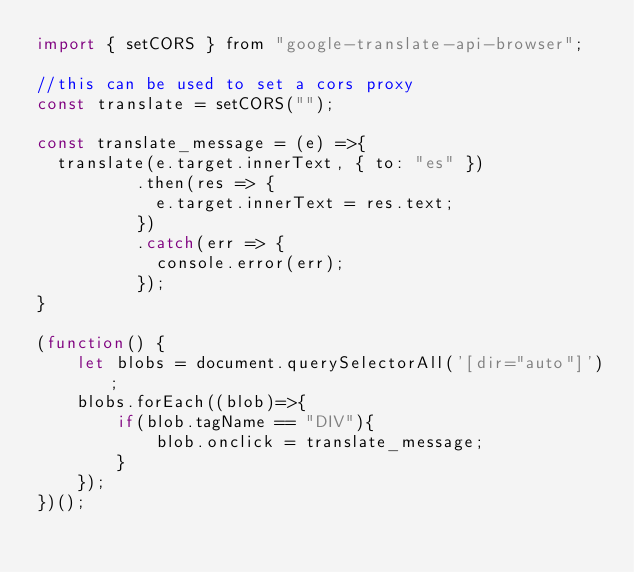<code> <loc_0><loc_0><loc_500><loc_500><_JavaScript_>import { setCORS } from "google-translate-api-browser";

//this can be used to set a cors proxy
const translate = setCORS("");

const translate_message = (e) =>{
  translate(e.target.innerText, { to: "es" })
          .then(res => {
            e.target.innerText = res.text;
          })
          .catch(err => {
            console.error(err);
          });
}

(function() {
	let blobs = document.querySelectorAll('[dir="auto"]');
    blobs.forEach((blob)=>{
        if(blob.tagName == "DIV"){
            blob.onclick = translate_message;
        }
    });
})();
</code> 